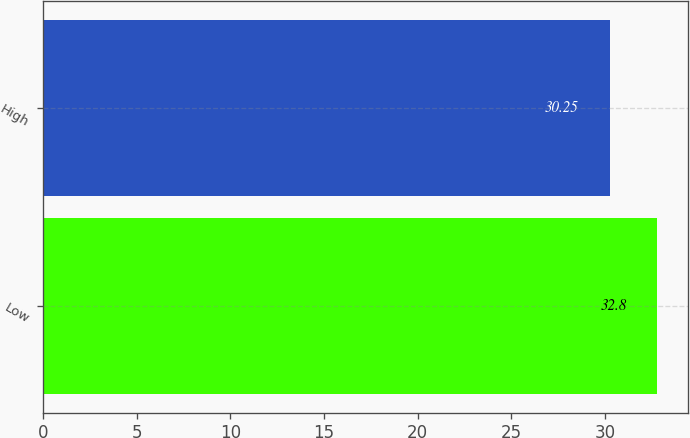<chart> <loc_0><loc_0><loc_500><loc_500><bar_chart><fcel>Low<fcel>High<nl><fcel>32.8<fcel>30.25<nl></chart> 